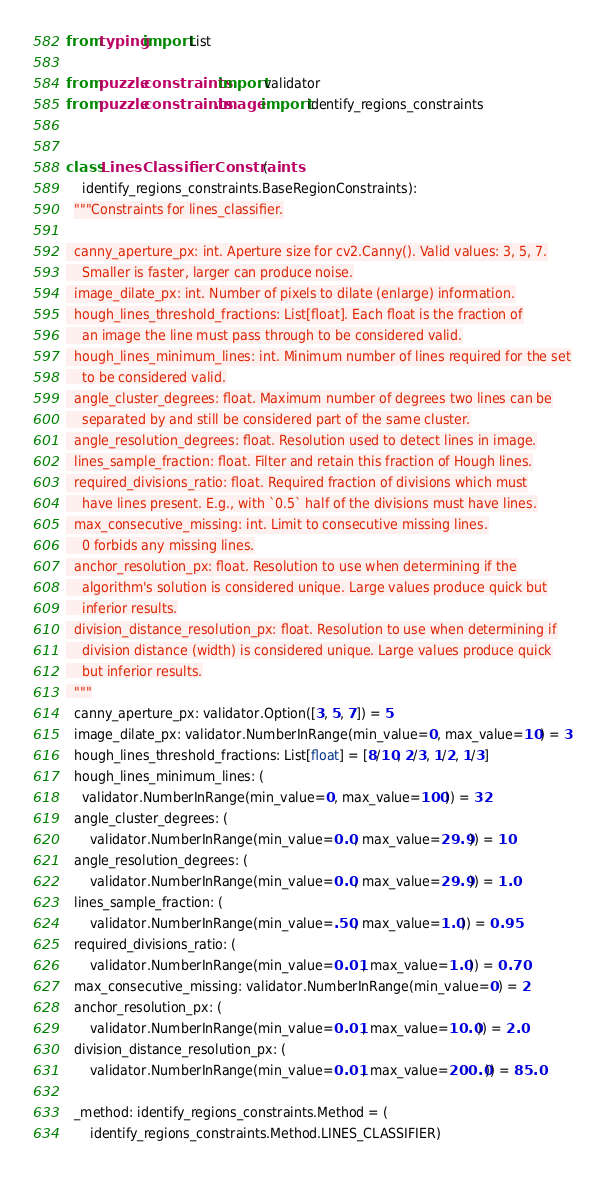Convert code to text. <code><loc_0><loc_0><loc_500><loc_500><_Python_>from typing import List

from puzzle.constraints import validator
from puzzle.constraints.image import identify_regions_constraints


class LinesClassifierConstraints(
    identify_regions_constraints.BaseRegionConstraints):
  """Constraints for lines_classifier.

  canny_aperture_px: int. Aperture size for cv2.Canny(). Valid values: 3, 5, 7.
    Smaller is faster, larger can produce noise.
  image_dilate_px: int. Number of pixels to dilate (enlarge) information.
  hough_lines_threshold_fractions: List[float]. Each float is the fraction of
    an image the line must pass through to be considered valid.
  hough_lines_minimum_lines: int. Minimum number of lines required for the set
    to be considered valid.
  angle_cluster_degrees: float. Maximum number of degrees two lines can be
    separated by and still be considered part of the same cluster.
  angle_resolution_degrees: float. Resolution used to detect lines in image.
  lines_sample_fraction: float. Filter and retain this fraction of Hough lines.
  required_divisions_ratio: float. Required fraction of divisions which must
    have lines present. E.g., with `0.5` half of the divisions must have lines.
  max_consecutive_missing: int. Limit to consecutive missing lines.
    0 forbids any missing lines.
  anchor_resolution_px: float. Resolution to use when determining if the
    algorithm's solution is considered unique. Large values produce quick but
    inferior results.
  division_distance_resolution_px: float. Resolution to use when determining if
    division distance (width) is considered unique. Large values produce quick
    but inferior results.
  """
  canny_aperture_px: validator.Option([3, 5, 7]) = 5
  image_dilate_px: validator.NumberInRange(min_value=0, max_value=10) = 3
  hough_lines_threshold_fractions: List[float] = [8/10, 2/3, 1/2, 1/3]
  hough_lines_minimum_lines: (
    validator.NumberInRange(min_value=0, max_value=100)) = 32
  angle_cluster_degrees: (
      validator.NumberInRange(min_value=0.0, max_value=29.9)) = 10
  angle_resolution_degrees: (
      validator.NumberInRange(min_value=0.0, max_value=29.9)) = 1.0
  lines_sample_fraction: (
      validator.NumberInRange(min_value=.50, max_value=1.0)) = 0.95
  required_divisions_ratio: (
      validator.NumberInRange(min_value=0.01, max_value=1.0)) = 0.70
  max_consecutive_missing: validator.NumberInRange(min_value=0) = 2
  anchor_resolution_px: (
      validator.NumberInRange(min_value=0.01, max_value=10.0)) = 2.0
  division_distance_resolution_px: (
      validator.NumberInRange(min_value=0.01, max_value=200.0)) = 85.0

  _method: identify_regions_constraints.Method = (
      identify_regions_constraints.Method.LINES_CLASSIFIER)
</code> 